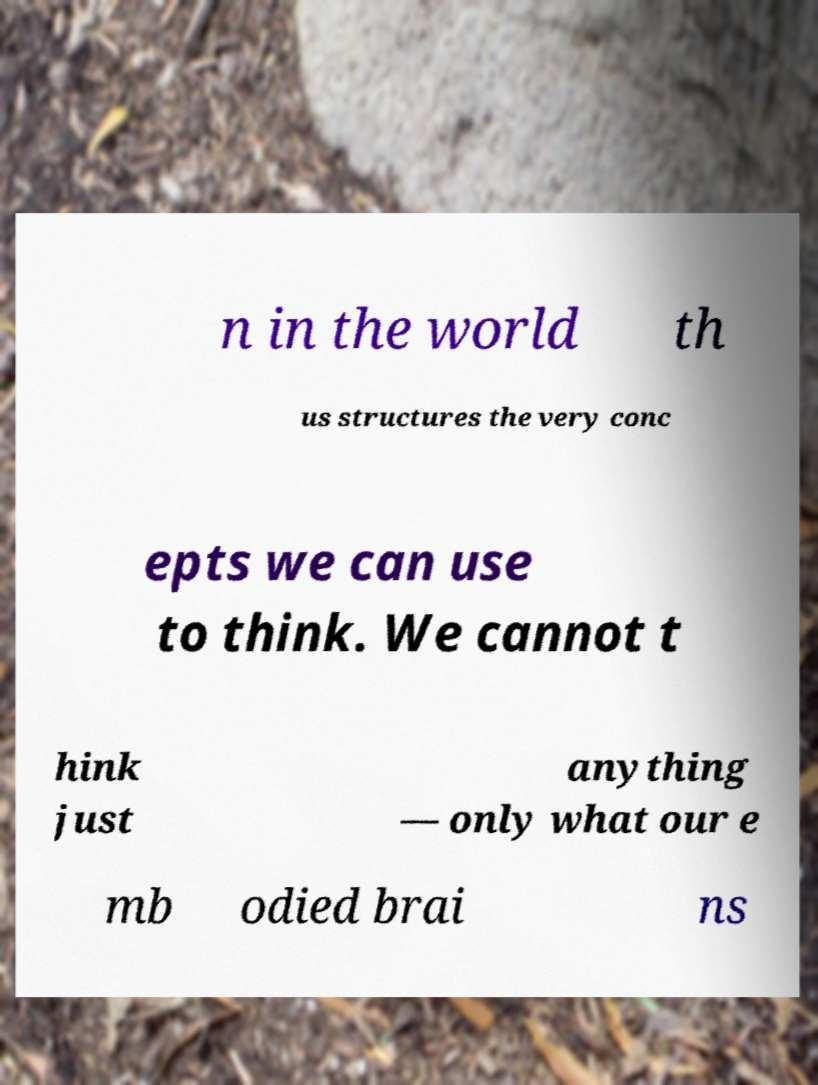Could you extract and type out the text from this image? n in the world th us structures the very conc epts we can use to think. We cannot t hink just anything — only what our e mb odied brai ns 